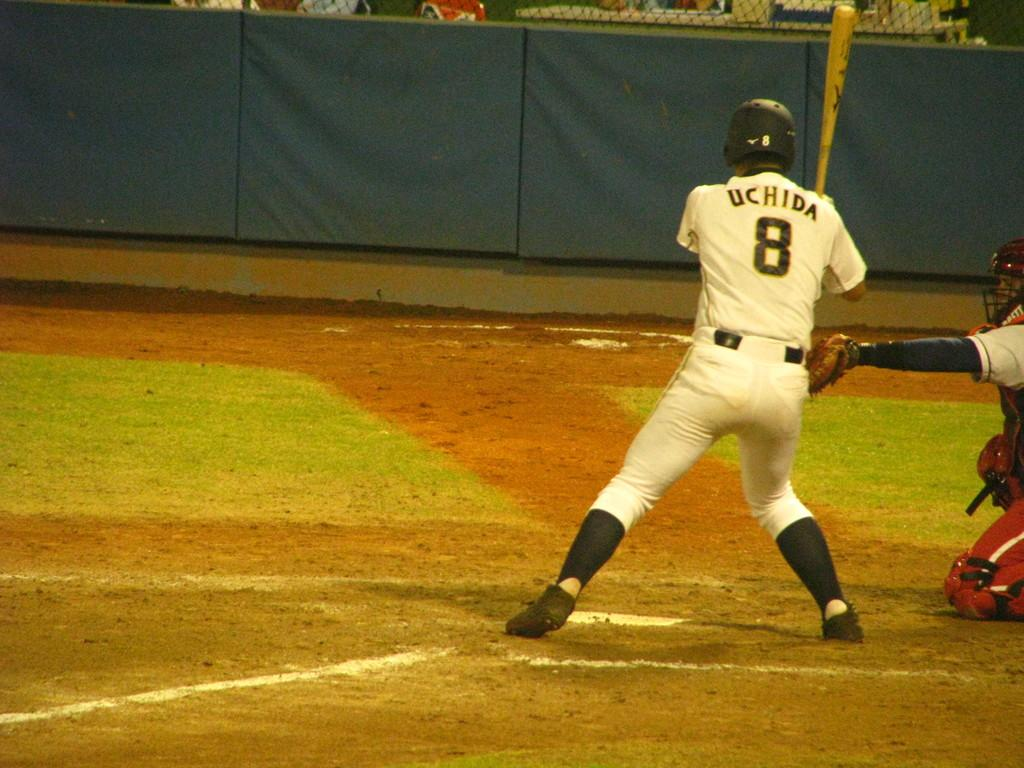Provide a one-sentence caption for the provided image. Baseball player getting ready to hit the ball, he is wearing #8 Uchida. 